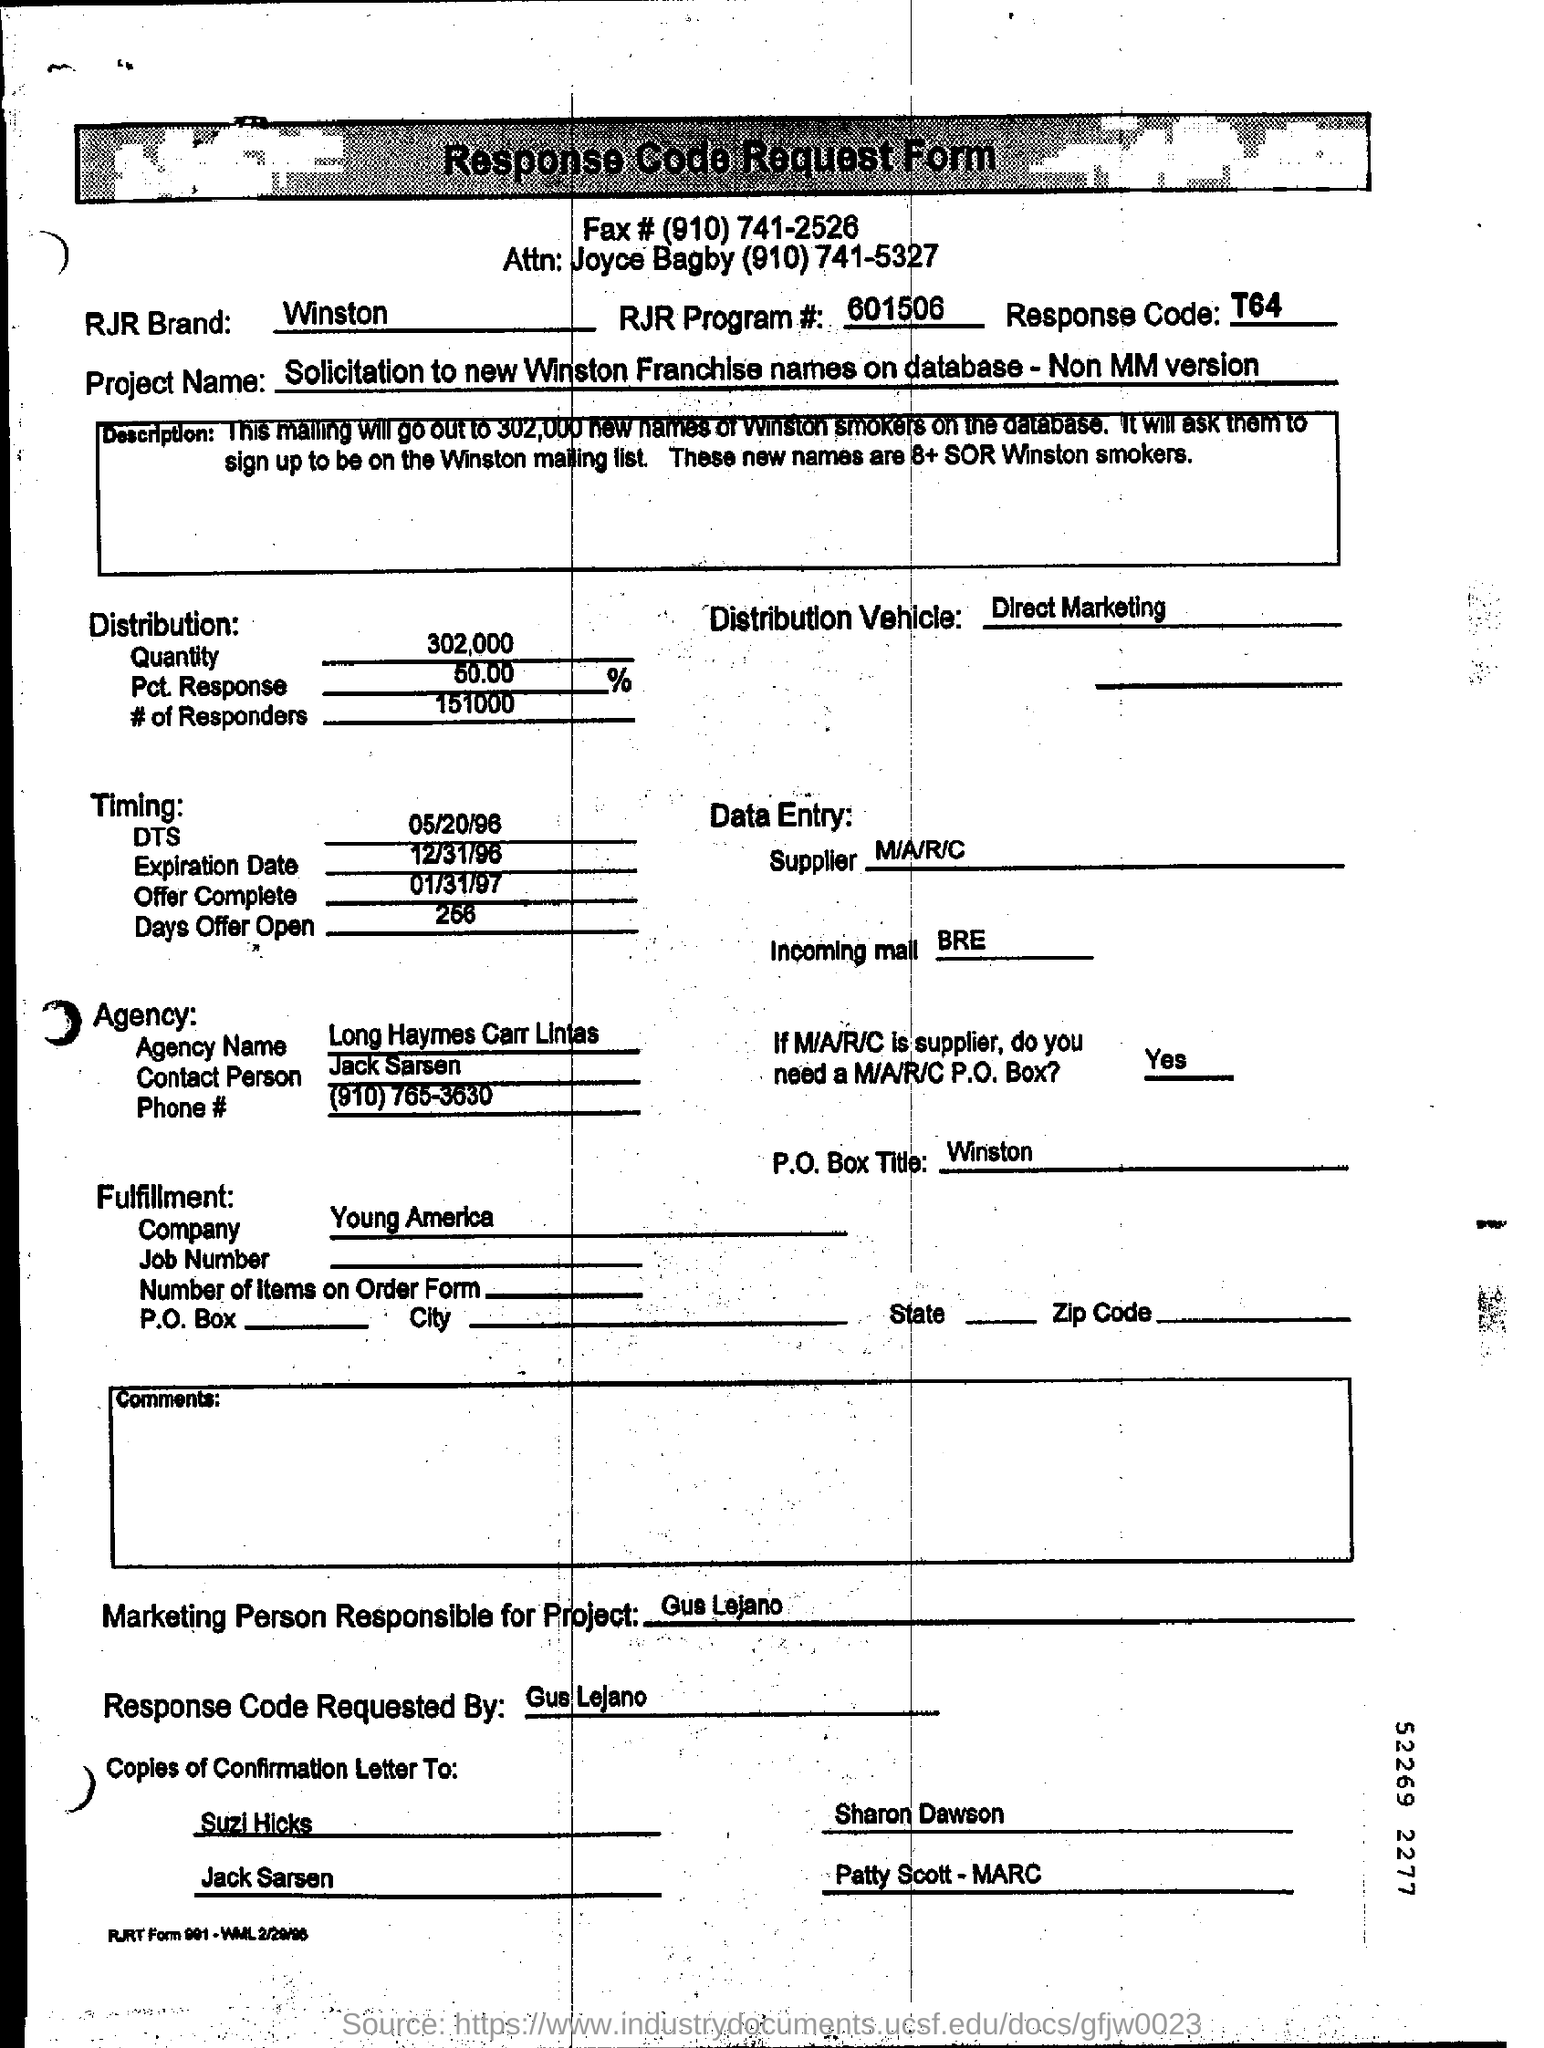Point out several critical features in this image. The quantity mentioned in the distribution is 302,000... The contact person of the agency is Jack Sarsen. 